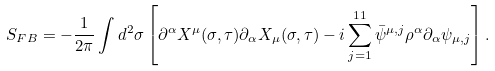Convert formula to latex. <formula><loc_0><loc_0><loc_500><loc_500>S _ { F B } = - \frac { 1 } { 2 \pi } \int d ^ { 2 } \sigma \left [ \partial ^ { \alpha } X ^ { \mu } ( \sigma , \tau ) \partial _ { \alpha } X _ { \mu } ( \sigma , \tau ) - i \sum _ { j = 1 } ^ { 1 1 } \bar { \psi } ^ { \mu , j } \rho ^ { \alpha } \partial _ { \alpha } \psi _ { \mu , j } \right ] .</formula> 